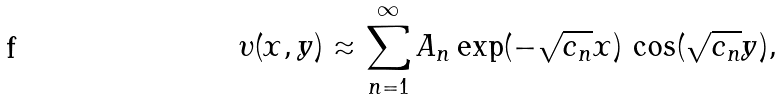<formula> <loc_0><loc_0><loc_500><loc_500>\upsilon ( x , y ) \approx \sum _ { n = 1 } ^ { \infty } A _ { n } \exp ( - \sqrt { c _ { n } } x ) \, \cos ( \sqrt { c _ { n } } y ) ,</formula> 